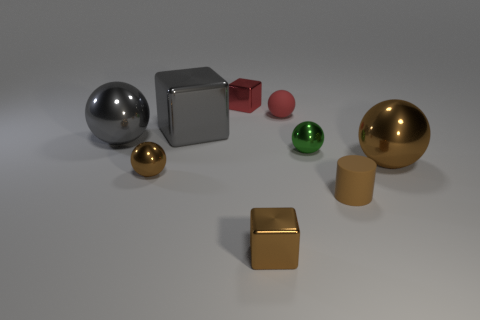Add 1 tiny purple cubes. How many objects exist? 10 Subtract all brown spheres. How many spheres are left? 3 Subtract all red spheres. How many spheres are left? 4 Subtract all cyan cylinders. How many brown spheres are left? 2 Add 3 large brown spheres. How many large brown spheres exist? 4 Subtract 0 cyan balls. How many objects are left? 9 Subtract all cylinders. How many objects are left? 8 Subtract 2 cubes. How many cubes are left? 1 Subtract all purple balls. Subtract all cyan blocks. How many balls are left? 5 Subtract all brown metallic objects. Subtract all large gray spheres. How many objects are left? 5 